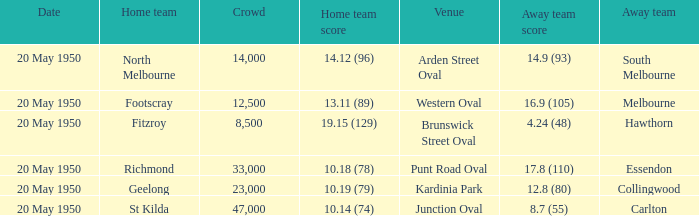What was the date of the game when the away team was south melbourne? 20 May 1950. 